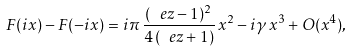<formula> <loc_0><loc_0><loc_500><loc_500>F ( i x ) - F ( - i x ) = i \pi \, \frac { ( \ e z - 1 ) ^ { 2 } } { 4 \, ( \ e z + 1 ) } \, x ^ { 2 } - i \gamma \, x ^ { 3 } + O ( x ^ { 4 } ) ,</formula> 